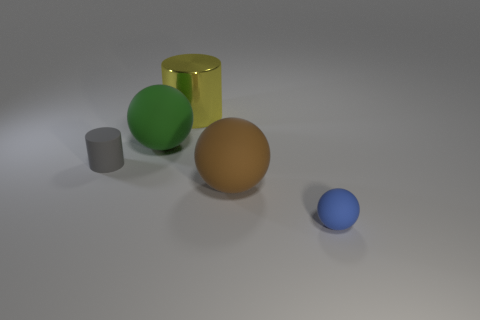Is there a tiny object behind the big matte object in front of the tiny object that is left of the blue rubber object?
Make the answer very short. Yes. What number of spheres are blue rubber things or matte things?
Offer a terse response. 3. There is a thing that is in front of the brown rubber thing; what material is it?
Provide a succinct answer. Rubber. There is a ball that is in front of the large brown rubber sphere; does it have the same color as the big matte object that is on the right side of the large metal object?
Your response must be concise. No. How many objects are either tiny brown metal blocks or big spheres?
Ensure brevity in your answer.  2. How many other objects are there of the same shape as the large green rubber object?
Make the answer very short. 2. Are the big object to the left of the large cylinder and the tiny thing that is to the right of the brown matte ball made of the same material?
Ensure brevity in your answer.  Yes. What shape is the big thing that is both in front of the big yellow thing and to the right of the green object?
Make the answer very short. Sphere. Are there any other things that are the same material as the yellow thing?
Provide a succinct answer. No. The big object that is on the right side of the green thing and behind the gray matte cylinder is made of what material?
Provide a short and direct response. Metal. 